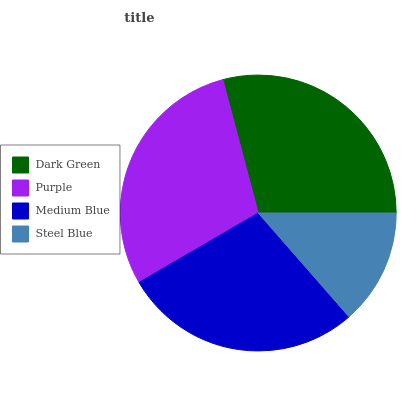Is Steel Blue the minimum?
Answer yes or no. Yes. Is Purple the maximum?
Answer yes or no. Yes. Is Medium Blue the minimum?
Answer yes or no. No. Is Medium Blue the maximum?
Answer yes or no. No. Is Purple greater than Medium Blue?
Answer yes or no. Yes. Is Medium Blue less than Purple?
Answer yes or no. Yes. Is Medium Blue greater than Purple?
Answer yes or no. No. Is Purple less than Medium Blue?
Answer yes or no. No. Is Dark Green the high median?
Answer yes or no. Yes. Is Medium Blue the low median?
Answer yes or no. Yes. Is Steel Blue the high median?
Answer yes or no. No. Is Dark Green the low median?
Answer yes or no. No. 